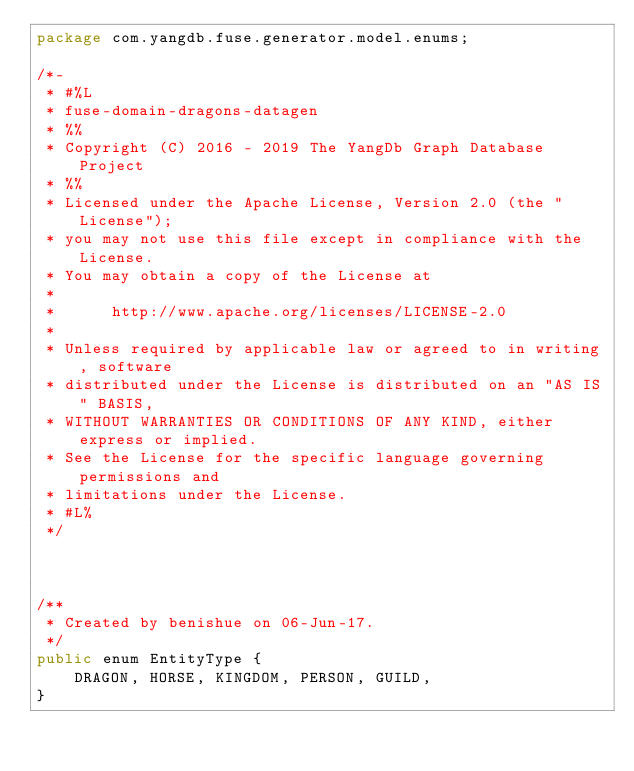Convert code to text. <code><loc_0><loc_0><loc_500><loc_500><_Java_>package com.yangdb.fuse.generator.model.enums;

/*-
 * #%L
 * fuse-domain-dragons-datagen
 * %%
 * Copyright (C) 2016 - 2019 The YangDb Graph Database Project
 * %%
 * Licensed under the Apache License, Version 2.0 (the "License");
 * you may not use this file except in compliance with the License.
 * You may obtain a copy of the License at
 * 
 *      http://www.apache.org/licenses/LICENSE-2.0
 * 
 * Unless required by applicable law or agreed to in writing, software
 * distributed under the License is distributed on an "AS IS" BASIS,
 * WITHOUT WARRANTIES OR CONDITIONS OF ANY KIND, either express or implied.
 * See the License for the specific language governing permissions and
 * limitations under the License.
 * #L%
 */



/**
 * Created by benishue on 06-Jun-17.
 */
public enum EntityType {
    DRAGON, HORSE, KINGDOM, PERSON, GUILD,
}
</code> 